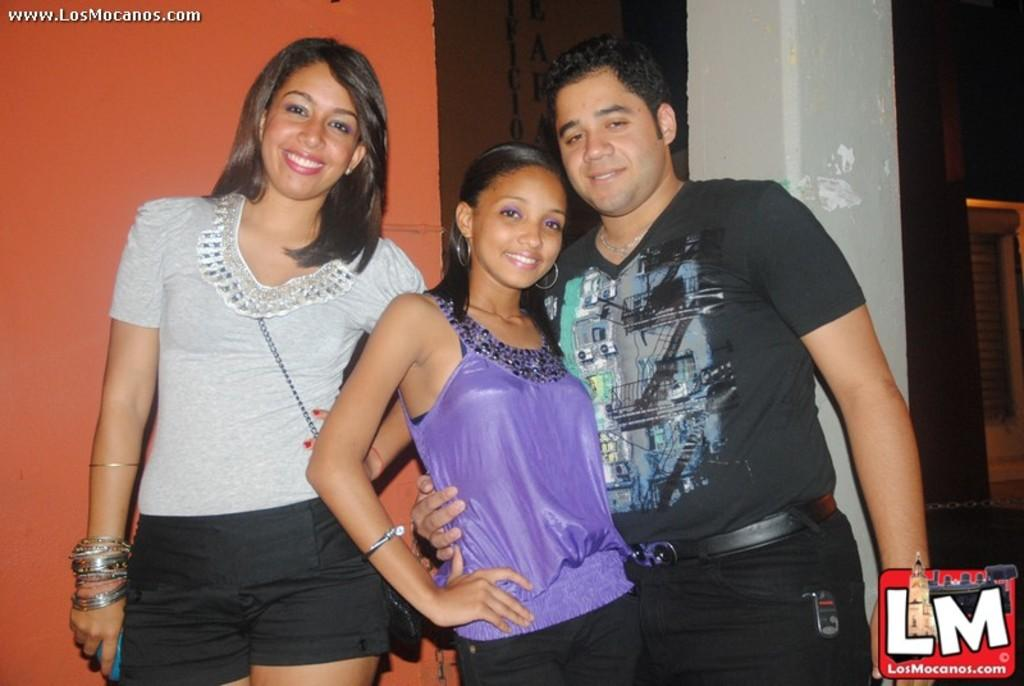Who or what can be seen in the image? There are people in the image. What can be seen in the background of the image? There is a wall, a pillar, and a door in the background of the image. Are there any marks or stamps on the image? Yes, there are watermarks in the top left and bottom right corners of the image. What is the rate of the cakes being served to the queen in the image? There are no cakes or queens present in the image, so it is not possible to determine a rate of service. 